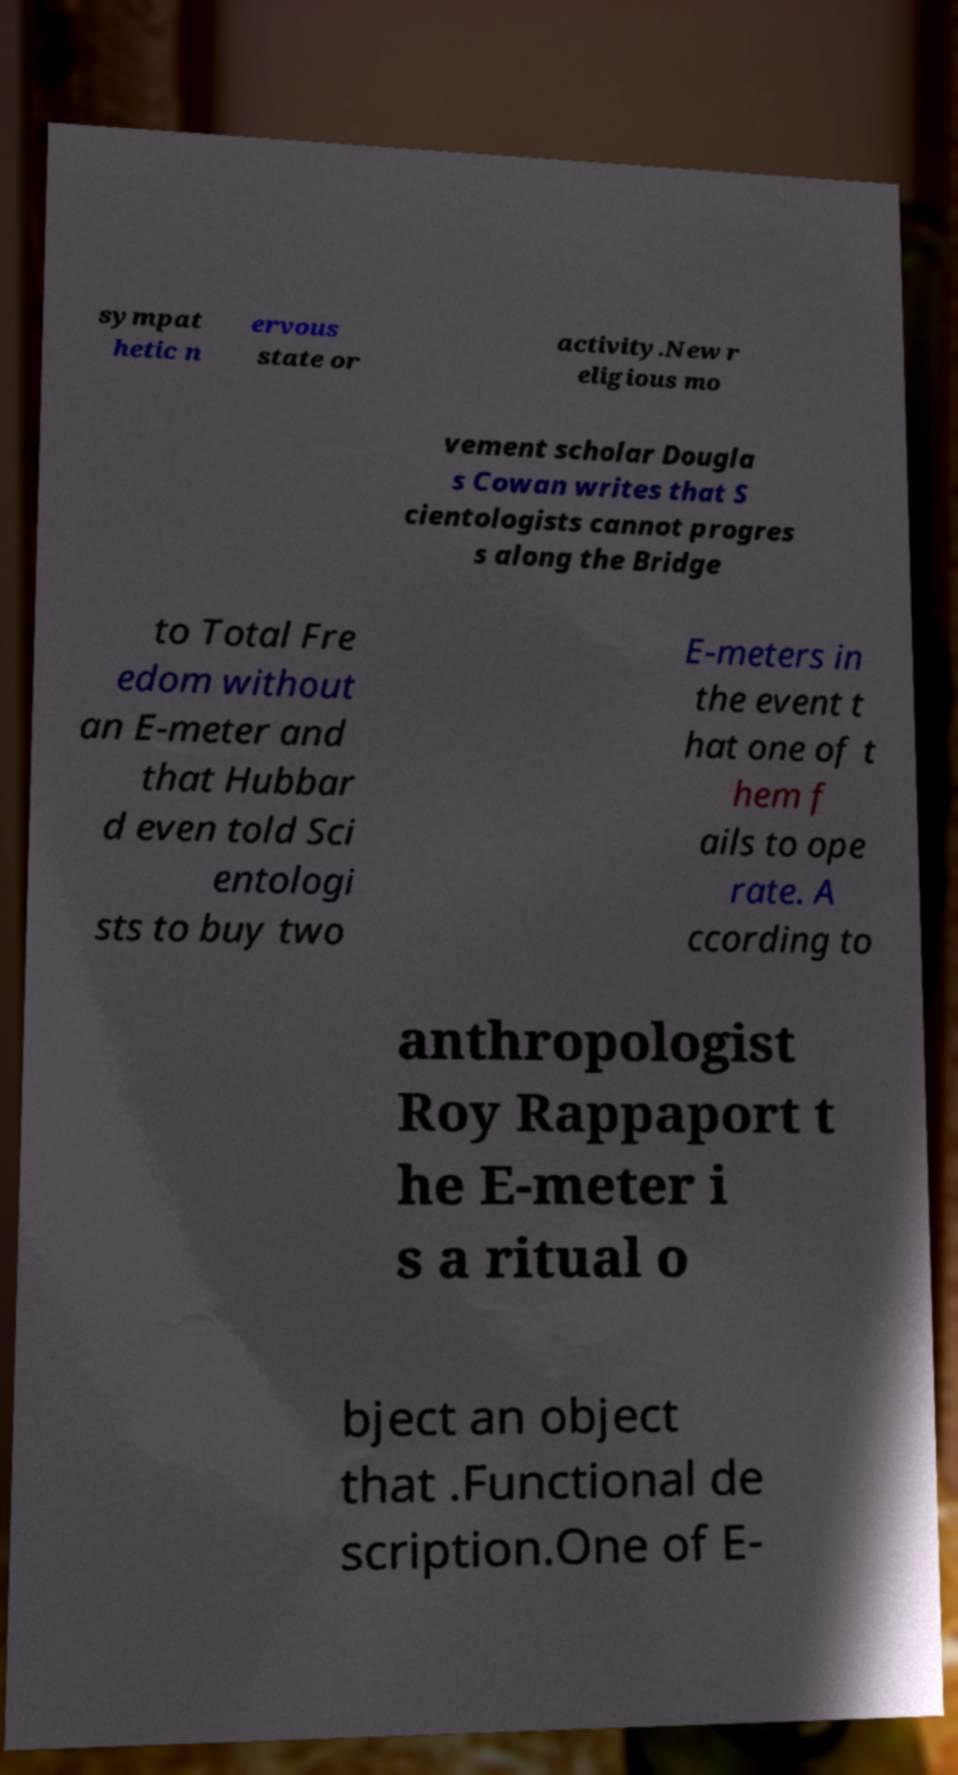Could you extract and type out the text from this image? sympat hetic n ervous state or activity.New r eligious mo vement scholar Dougla s Cowan writes that S cientologists cannot progres s along the Bridge to Total Fre edom without an E-meter and that Hubbar d even told Sci entologi sts to buy two E-meters in the event t hat one of t hem f ails to ope rate. A ccording to anthropologist Roy Rappaport t he E-meter i s a ritual o bject an object that .Functional de scription.One of E- 